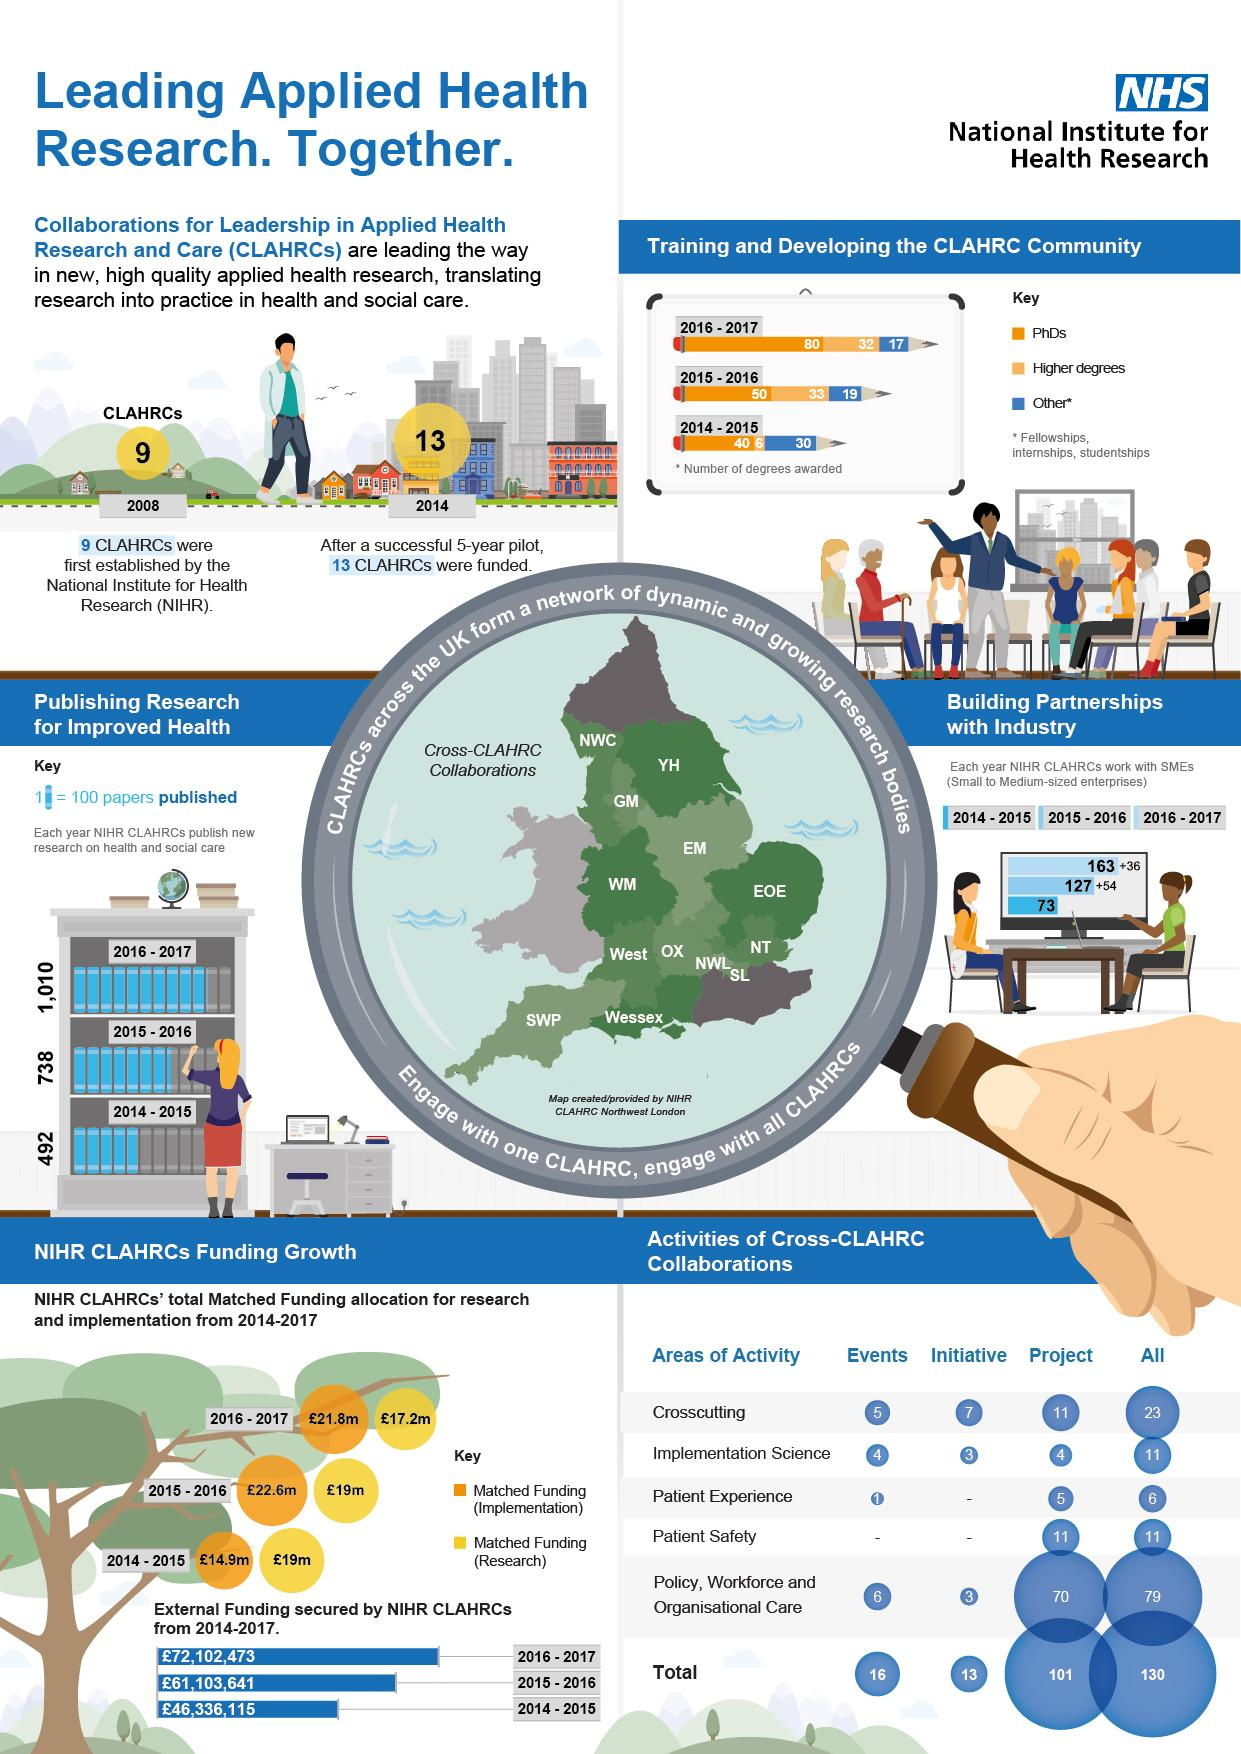Highlight a few significant elements in this photo. During the academic years 2014-2015, a total of 6 higher degrees were awarded. In the years 2016 and 2017, a total of 1,010 papers on health and social care were published. In the academic year 2015-2016, Bachelor's degrees were the second most commonly awarded degree, following higher degrees. In 2008, nine CLAHRCs had been established by the National Institute for Health Research (NIHR), and by 2014, an additional four CLAHRCs had been established by NIHR. In 2015-2016, the most degrees awarded were PhDs. 